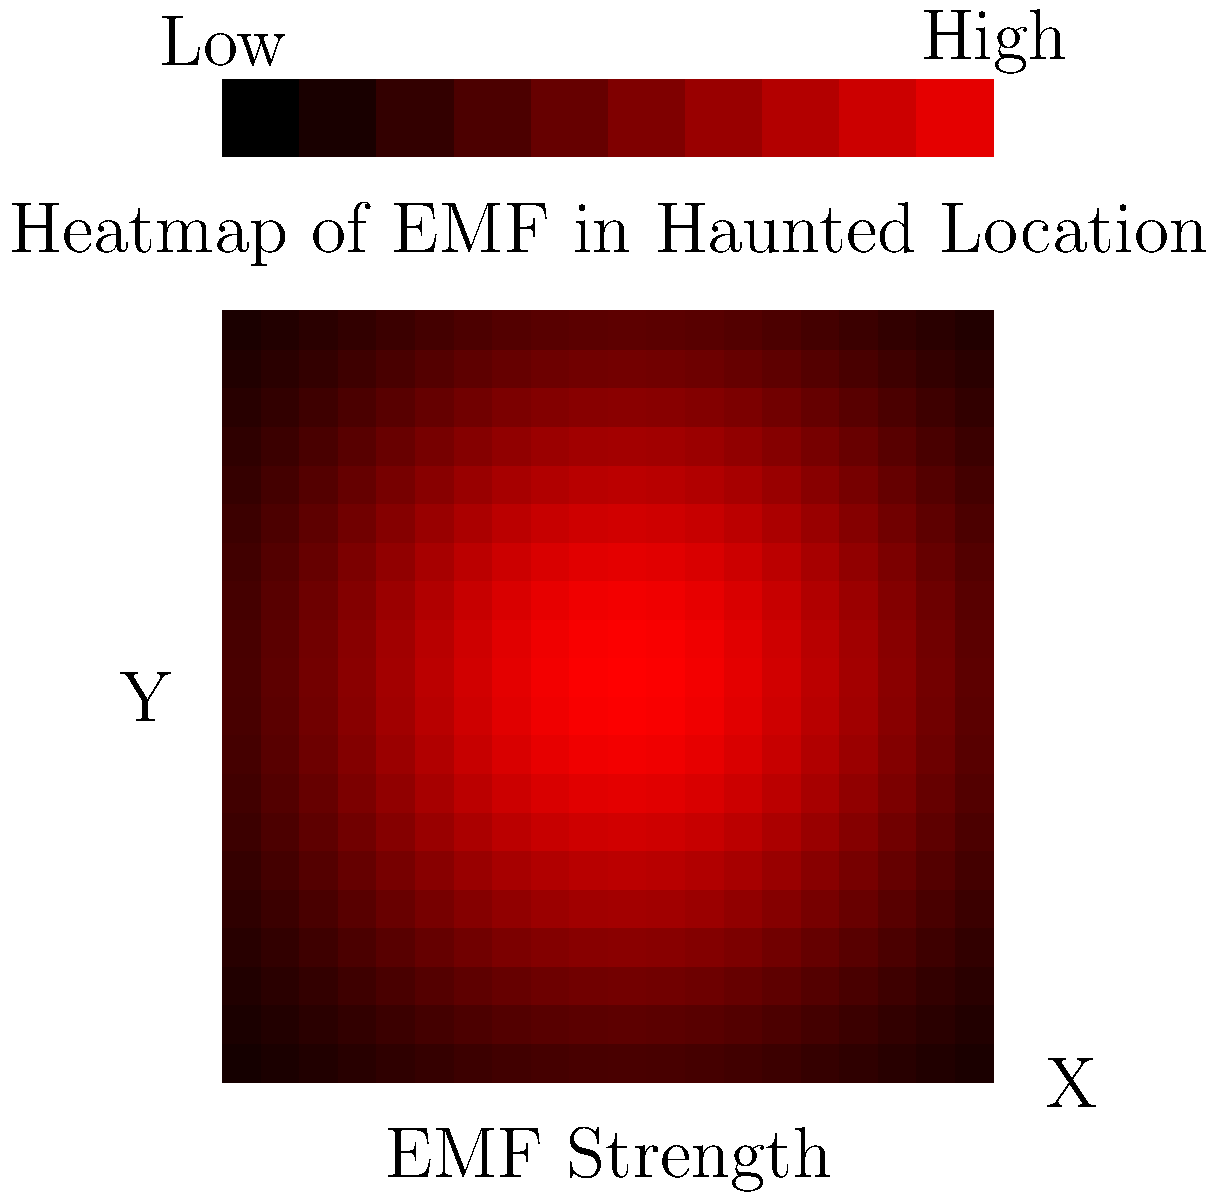In the context of developing a paranormal investigation app, you're tasked with implementing a feature to visualize electromagnetic field (EMF) strength in a haunted location. The image shows a heatmap overlay of EMF readings. What key factor should be considered when interpolating data points to create a smooth heatmap visualization, and how might this impact the interpretation of potential paranormal activity? To answer this question, let's break down the key considerations for interpolating EMF data in a paranormal investigation app:

1. Data collection: EMF readings are typically collected at discrete points in the investigated area.

2. Interpolation necessity: To create a smooth heatmap, we need to estimate EMF values between measured points.

3. Interpolation methods: Common techniques include:
   a) Linear interpolation
   b) Nearest neighbor interpolation
   c) Spline interpolation
   d) Kriging

4. Key factor - Spatial resolution:
   The distance between data points significantly affects the interpolation accuracy. Higher spatial resolution (more closely spaced measurements) generally leads to more accurate interpolations.

5. Impact on paranormal activity interpretation:
   a) Low resolution: May miss localized EMF anomalies, potentially overlooking paranormal hotspots.
   b) High resolution: Can reveal fine details in EMF variations, but may also introduce noise.

6. Trade-offs:
   a) Higher resolution requires more time and resources for data collection.
   b) Lower resolution is faster but may oversimplify the EMF landscape.

7. Paranormal context:
   EMF anomalies are often associated with potential paranormal activity. The interpolation method and resolution can affect the identification of these anomalies.

8. App implementation:
   The chosen interpolation method should balance accuracy, computational efficiency, and the app's real-time performance requirements.

In conclusion, the key factor to consider is the spatial resolution of the data points. It directly influences the accuracy of the interpolation and, consequently, the interpretation of potential paranormal activity.
Answer: Spatial resolution of data points 